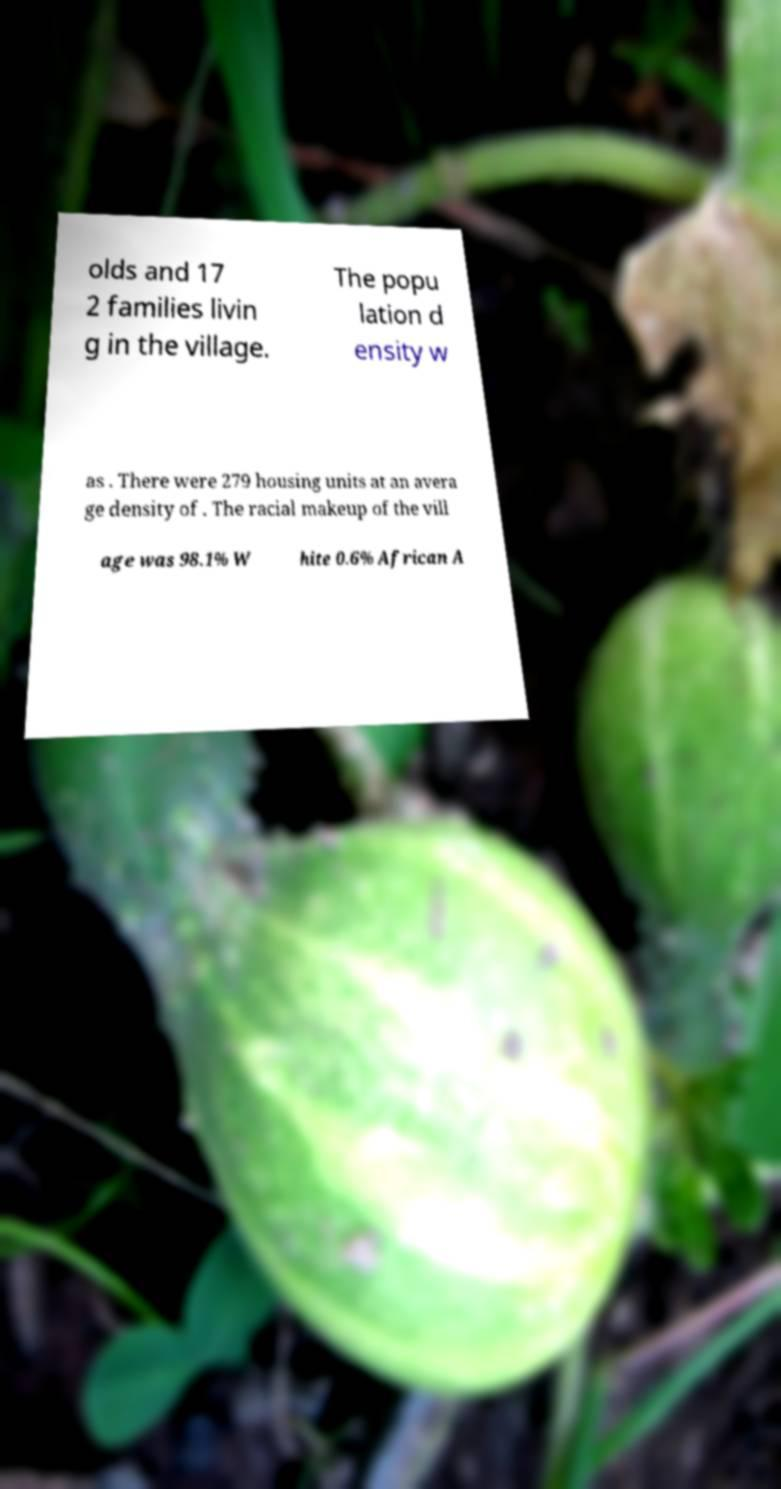Could you assist in decoding the text presented in this image and type it out clearly? olds and 17 2 families livin g in the village. The popu lation d ensity w as . There were 279 housing units at an avera ge density of . The racial makeup of the vill age was 98.1% W hite 0.6% African A 